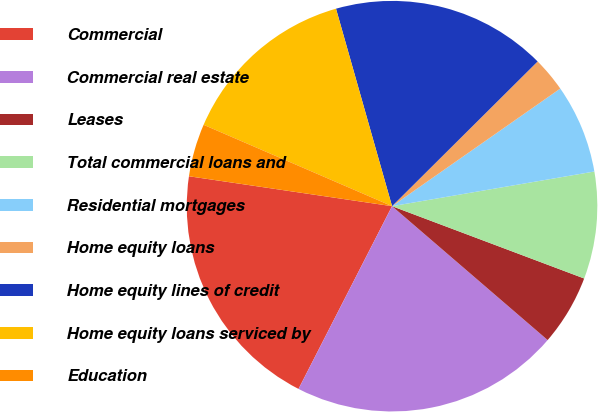Convert chart to OTSL. <chart><loc_0><loc_0><loc_500><loc_500><pie_chart><fcel>Commercial<fcel>Commercial real estate<fcel>Leases<fcel>Total commercial loans and<fcel>Residential mortgages<fcel>Home equity loans<fcel>Home equity lines of credit<fcel>Home equity loans serviced by<fcel>Education<nl><fcel>19.8%<fcel>21.22%<fcel>5.58%<fcel>8.43%<fcel>7.01%<fcel>2.74%<fcel>16.95%<fcel>14.11%<fcel>4.16%<nl></chart> 